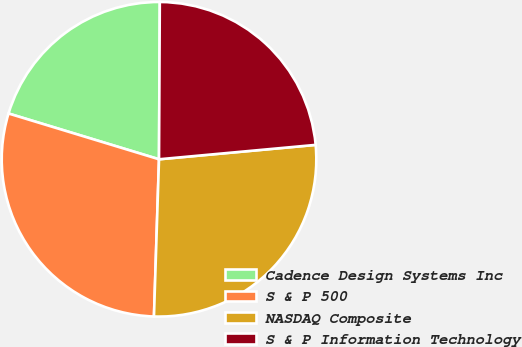Convert chart. <chart><loc_0><loc_0><loc_500><loc_500><pie_chart><fcel>Cadence Design Systems Inc<fcel>S & P 500<fcel>NASDAQ Composite<fcel>S & P Information Technology<nl><fcel>20.38%<fcel>29.19%<fcel>26.97%<fcel>23.46%<nl></chart> 